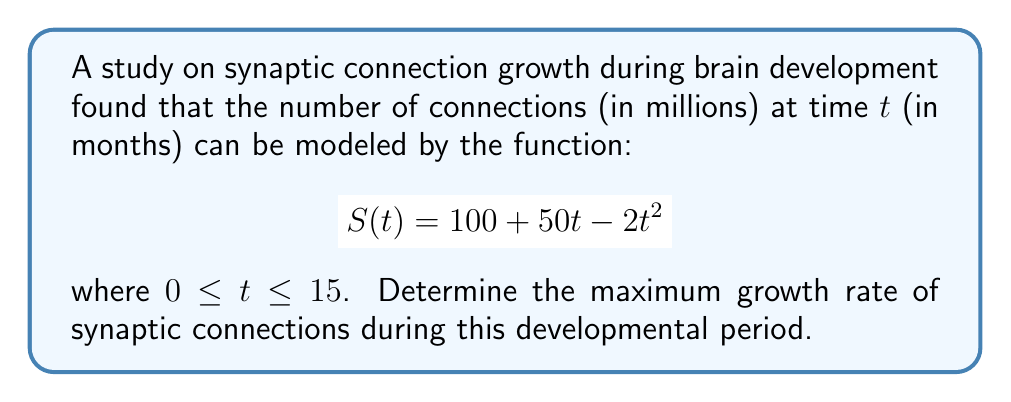Provide a solution to this math problem. To find the maximum growth rate, we need to follow these steps:

1) The growth rate is given by the derivative of S(t). Let's call this S'(t).

   $$S'(t) = 50 - 4t$$

2) The growth rate is maximum when S''(t) = 0, or at the endpoints of the interval.

3) Find S''(t):

   $$S''(t) = -4$$

4) Since S''(t) is constant and negative, the maximum growth rate occurs at the beginning of the interval, when t = 0.

5) Evaluate S'(0):

   $$S'(0) = 50 - 4(0) = 50$$

Therefore, the maximum growth rate is 50 million connections per month, occurring at the beginning of the developmental period.
Answer: 50 million connections/month 